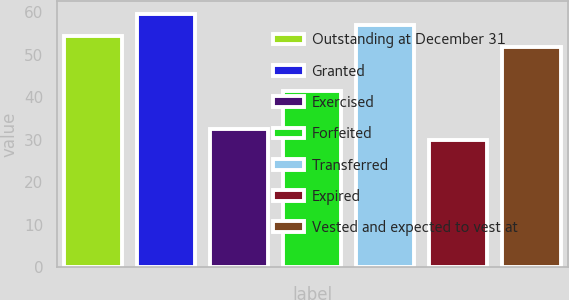Convert chart to OTSL. <chart><loc_0><loc_0><loc_500><loc_500><bar_chart><fcel>Outstanding at December 31<fcel>Granted<fcel>Exercised<fcel>Forfeited<fcel>Transferred<fcel>Expired<fcel>Vested and expected to vest at<nl><fcel>54.35<fcel>59.59<fcel>32.46<fcel>41.44<fcel>56.97<fcel>29.84<fcel>51.73<nl></chart> 